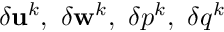Convert formula to latex. <formula><loc_0><loc_0><loc_500><loc_500>\delta u ^ { k } , \ \delta w ^ { k } , \ \delta p ^ { k } , \ \delta q ^ { k }</formula> 